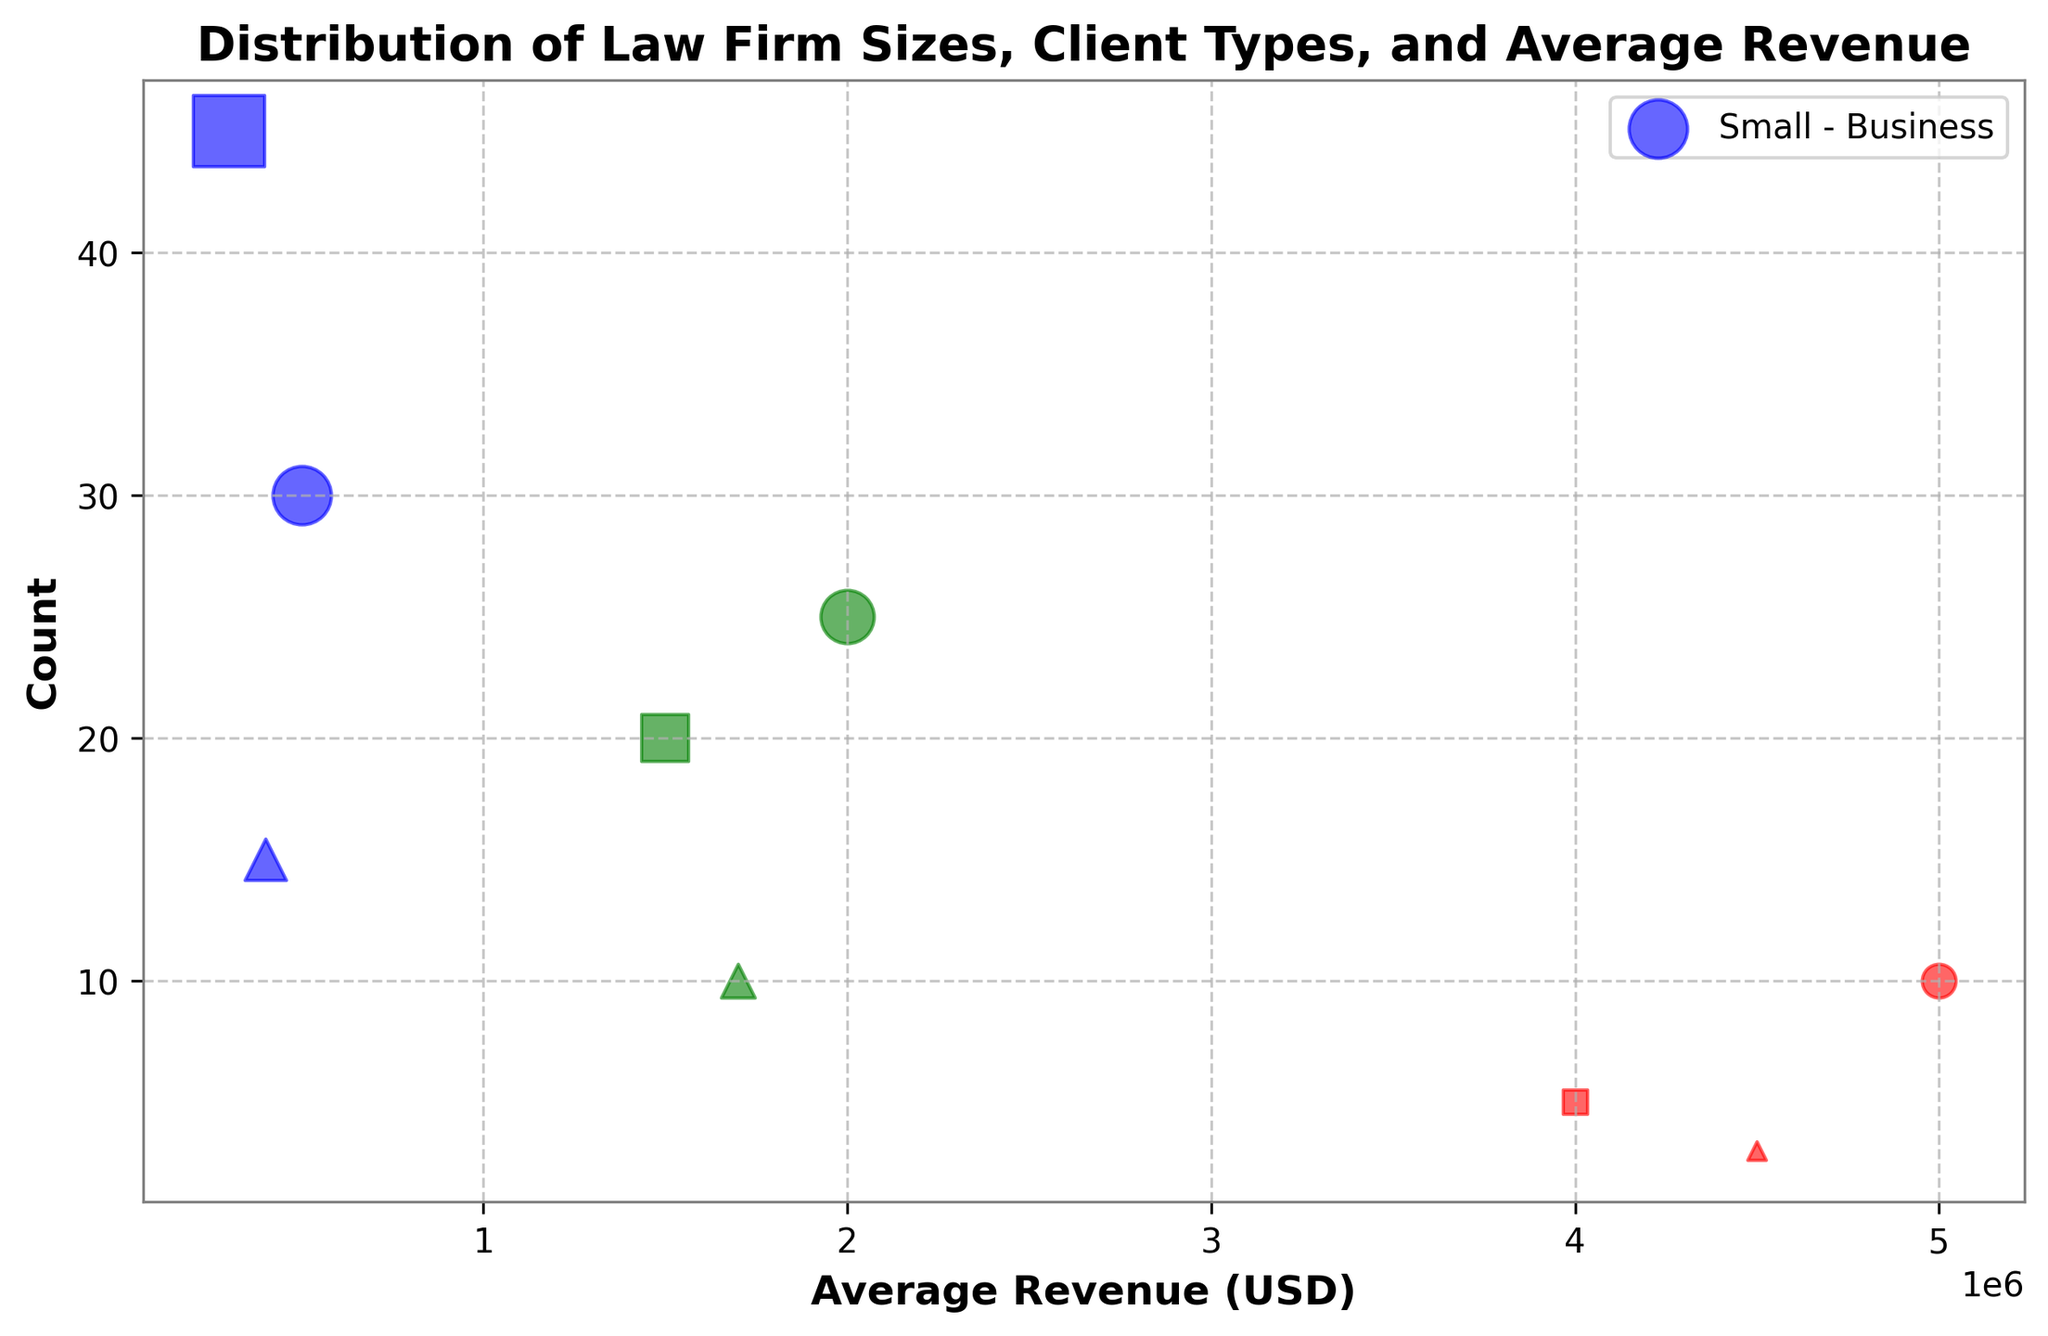What is the firm size that deals with the highest revenue clients? Checking the scatter plot, the highest revenue is 5,000,000 USD and 4,500,000 USD, both are represented by red color dots (Large Firm size)
Answer: Large Between individual clients and non-profits, which client type has higher average revenue in small firms? Looking at small firms' scatter dots, the average revenue of individual clients (300,000 USD) is less than that of non-profits (400,000 USD)
Answer: Non-Profit Which client type has the highest count within medium firms? Look at the green dots (medium firms). For medium firms, individual clients have the highest count (20)
Answer: Individual What is the combined count of medium and large firms dealing with business clients? Summing up the counts: medium firms with business clients (25), large firms with business clients (10). Total is 25 + 10 = 35
Answer: 35 What is the average revenue of non-profit clients across all firm sizes? Averaging the revenues of non-profits: small (400,000 USD), medium (1,700,000 USD), large (4,500,000 USD). The average is (400,000 + 1,700,000 + 4,500,000) / 3 = 2,200,000 USD
Answer: 2,200,000 How does the count for small firms dealing with business clients compare to medium firms dealing with individual clients? Small firms with business clients (blue dots, circular markers) have a count of 30, medium firms with individual clients (green dots, square markers) have a count of 20. 30 > 20
Answer: Small firms with business clients have a higher count What color represents the highest client count in the chart? Highest client count is 45, which is represented by the blue color (small firm size)
Answer: Blue Which firm size is associated with triangular markers, and what client type do these markers represent? Triangular markers represent non-profit clients. According to the color coding, these markers appear in blue, green, and red colors, corresponding to small, medium, and large firm sizes
Answer: Non-Profit clients In large firms, which client type has the lowest average revenue and how much is it? Looking at large firms (red dots), individual clients have the lowest average revenue (4,000,000 USD)
Answer: Individual, 4,000,000 USD 